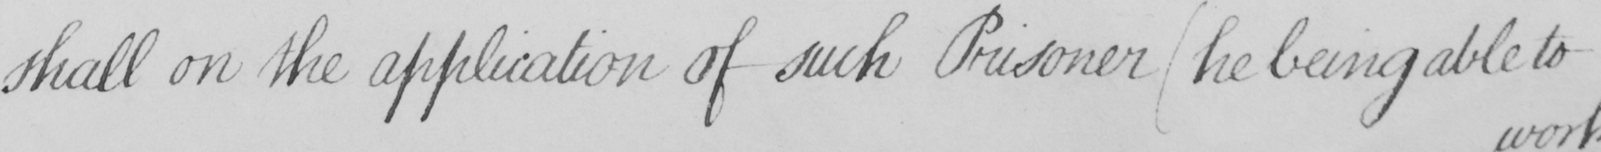What is written in this line of handwriting? shall on the application of such Prisoner  ( he being able to 